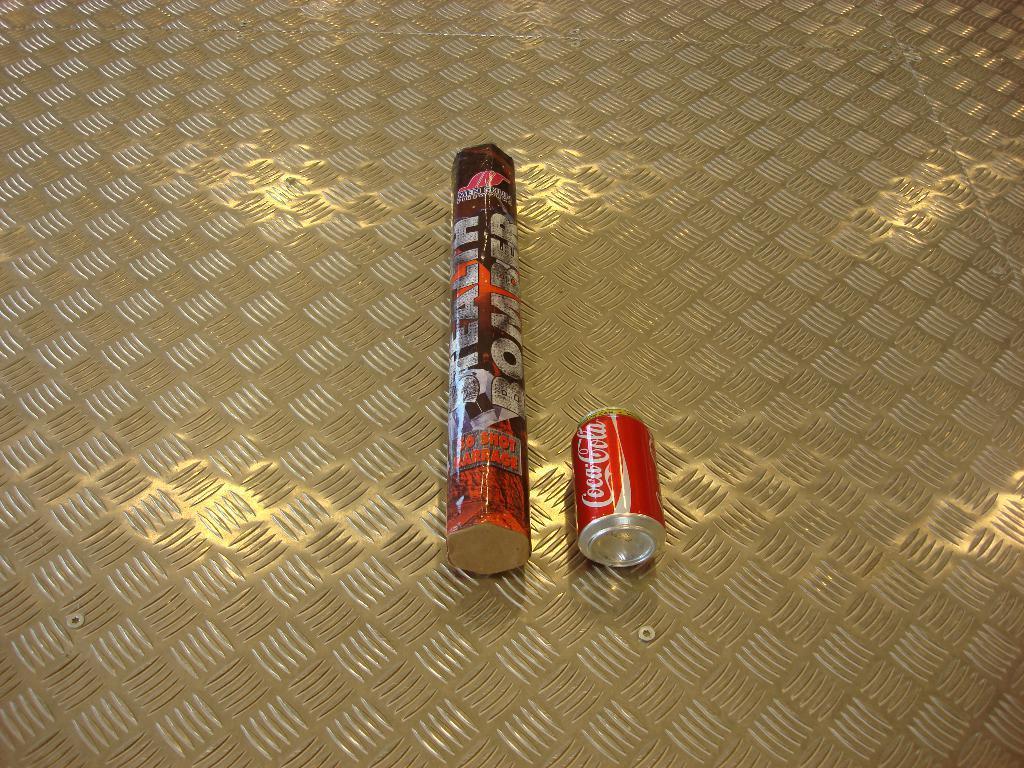Please provide a concise description of this image. In this picture there is one coca cola can and one bomber is placed on the steel sheet. 